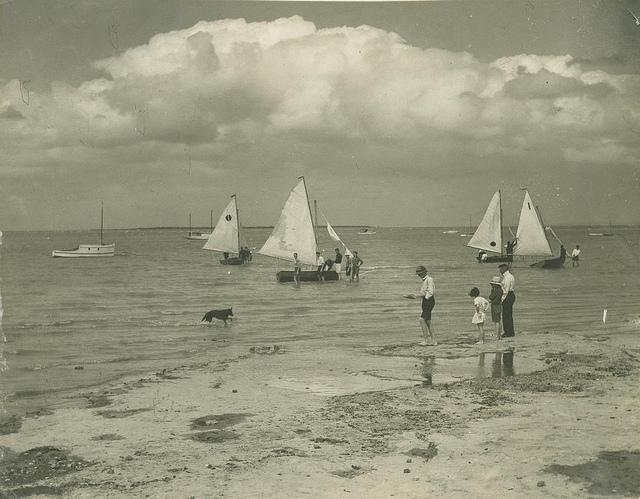What type of vehicles are in the water?

Choices:
A) yacht
B) sailboat
C) cruise ship
D) jet ski sailboat 